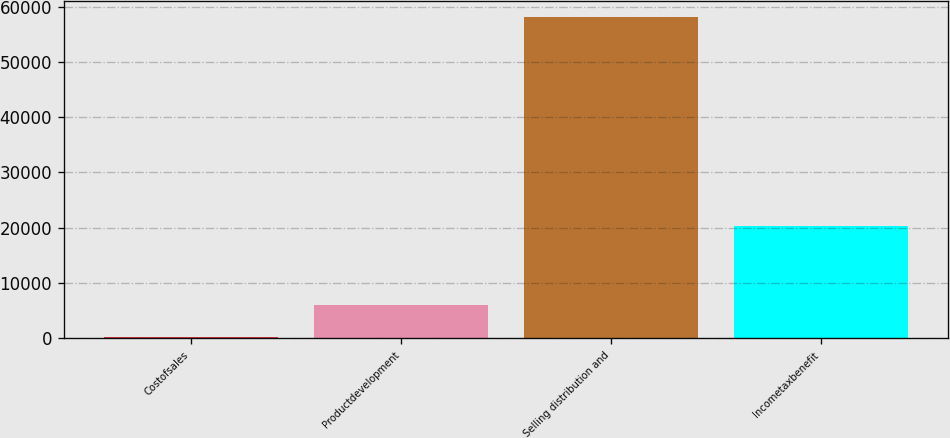Convert chart. <chart><loc_0><loc_0><loc_500><loc_500><bar_chart><fcel>Costofsales<fcel>Productdevelopment<fcel>Selling distribution and<fcel>Incometaxbenefit<nl><fcel>200<fcel>5997.6<fcel>58176<fcel>20298<nl></chart> 